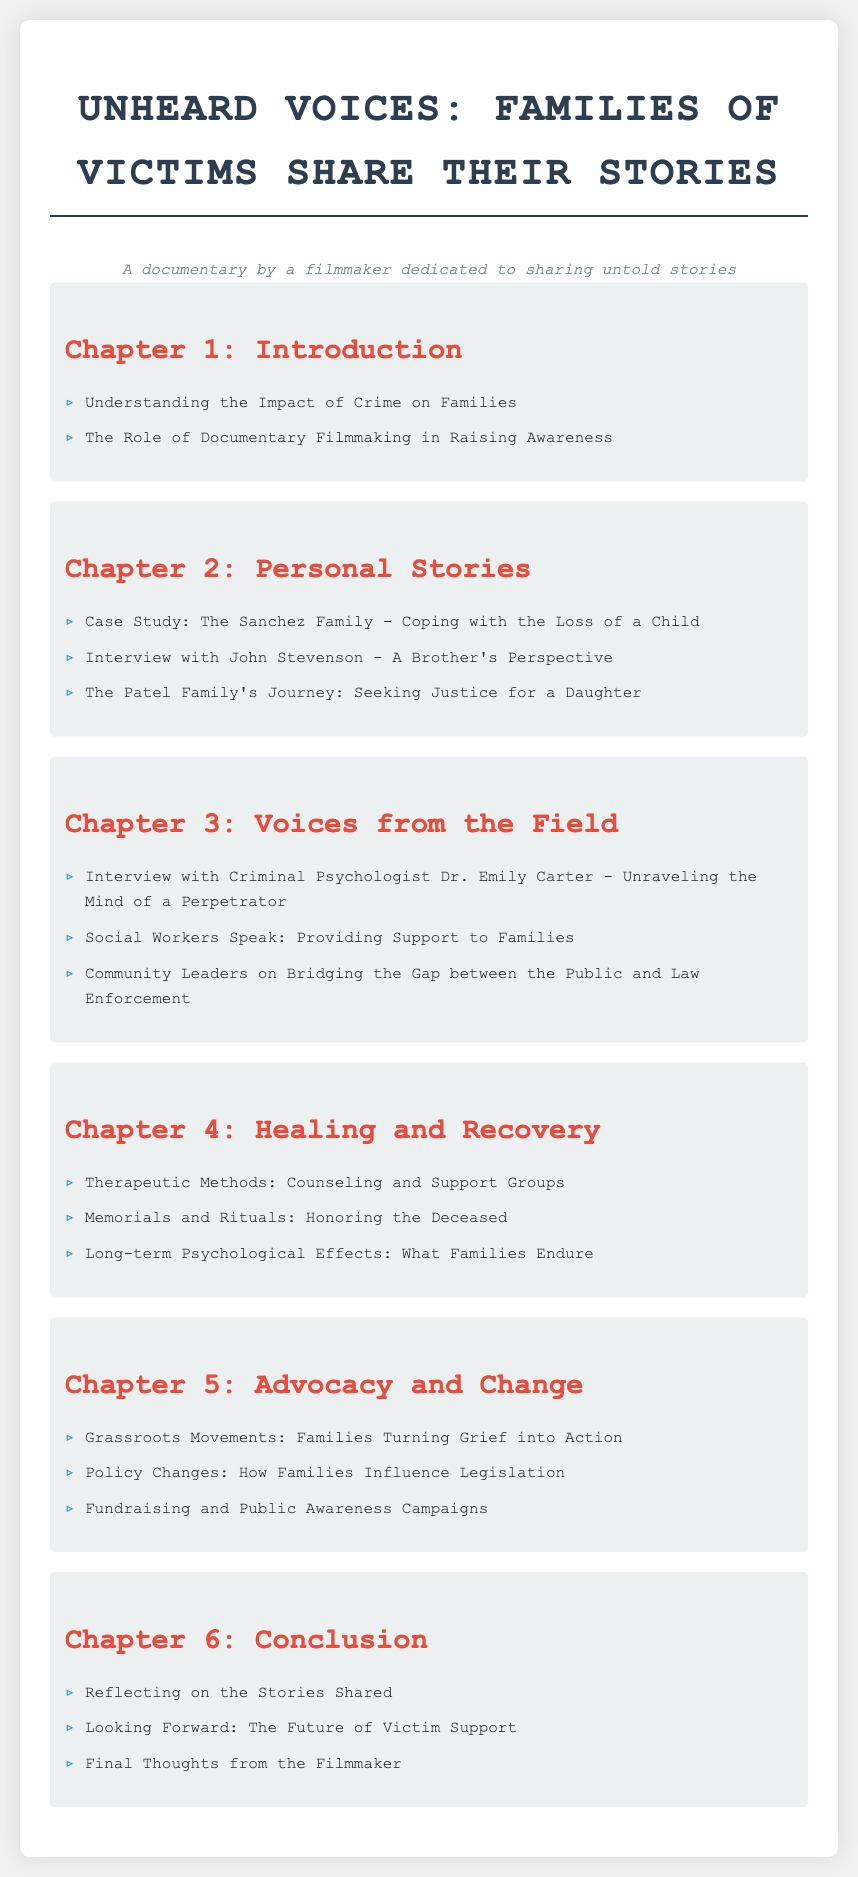What is the title of the documentary? The title is explicitly stated in the document's header.
Answer: Unheard Voices: Families of Victims Share Their Stories How many chapters are there in the document? The document lists six chapters in the table of contents.
Answer: 6 Who is the criminal psychologist interviewed in Chapter 3? The document specifically names the psychologist in the interview section of Chapter 3.
Answer: Dr. Emily Carter What does Chapter 4 focus on? The chapter title indicates its primary theme regarding healing processes.
Answer: Healing and Recovery Which family is highlighted in the case study in Chapter 2? The document refers to a specific family as the subject of a case study in Chapter 2.
Answer: The Sanchez Family What is one method of therapy mentioned in Chapter 4? The document lists therapeutic methods in the chapter on healing.
Answer: Counseling and Support Groups What is a goal of the grassroots movements discussed in Chapter 5? The document indicates the activists' aim through the title of Chapter 5.
Answer: Turning Grief into Action What is the final section of Chapter 6 about? The last part of Chapter 6 summarizes the filmmaker's perspectives.
Answer: Final Thoughts from the Filmmaker 